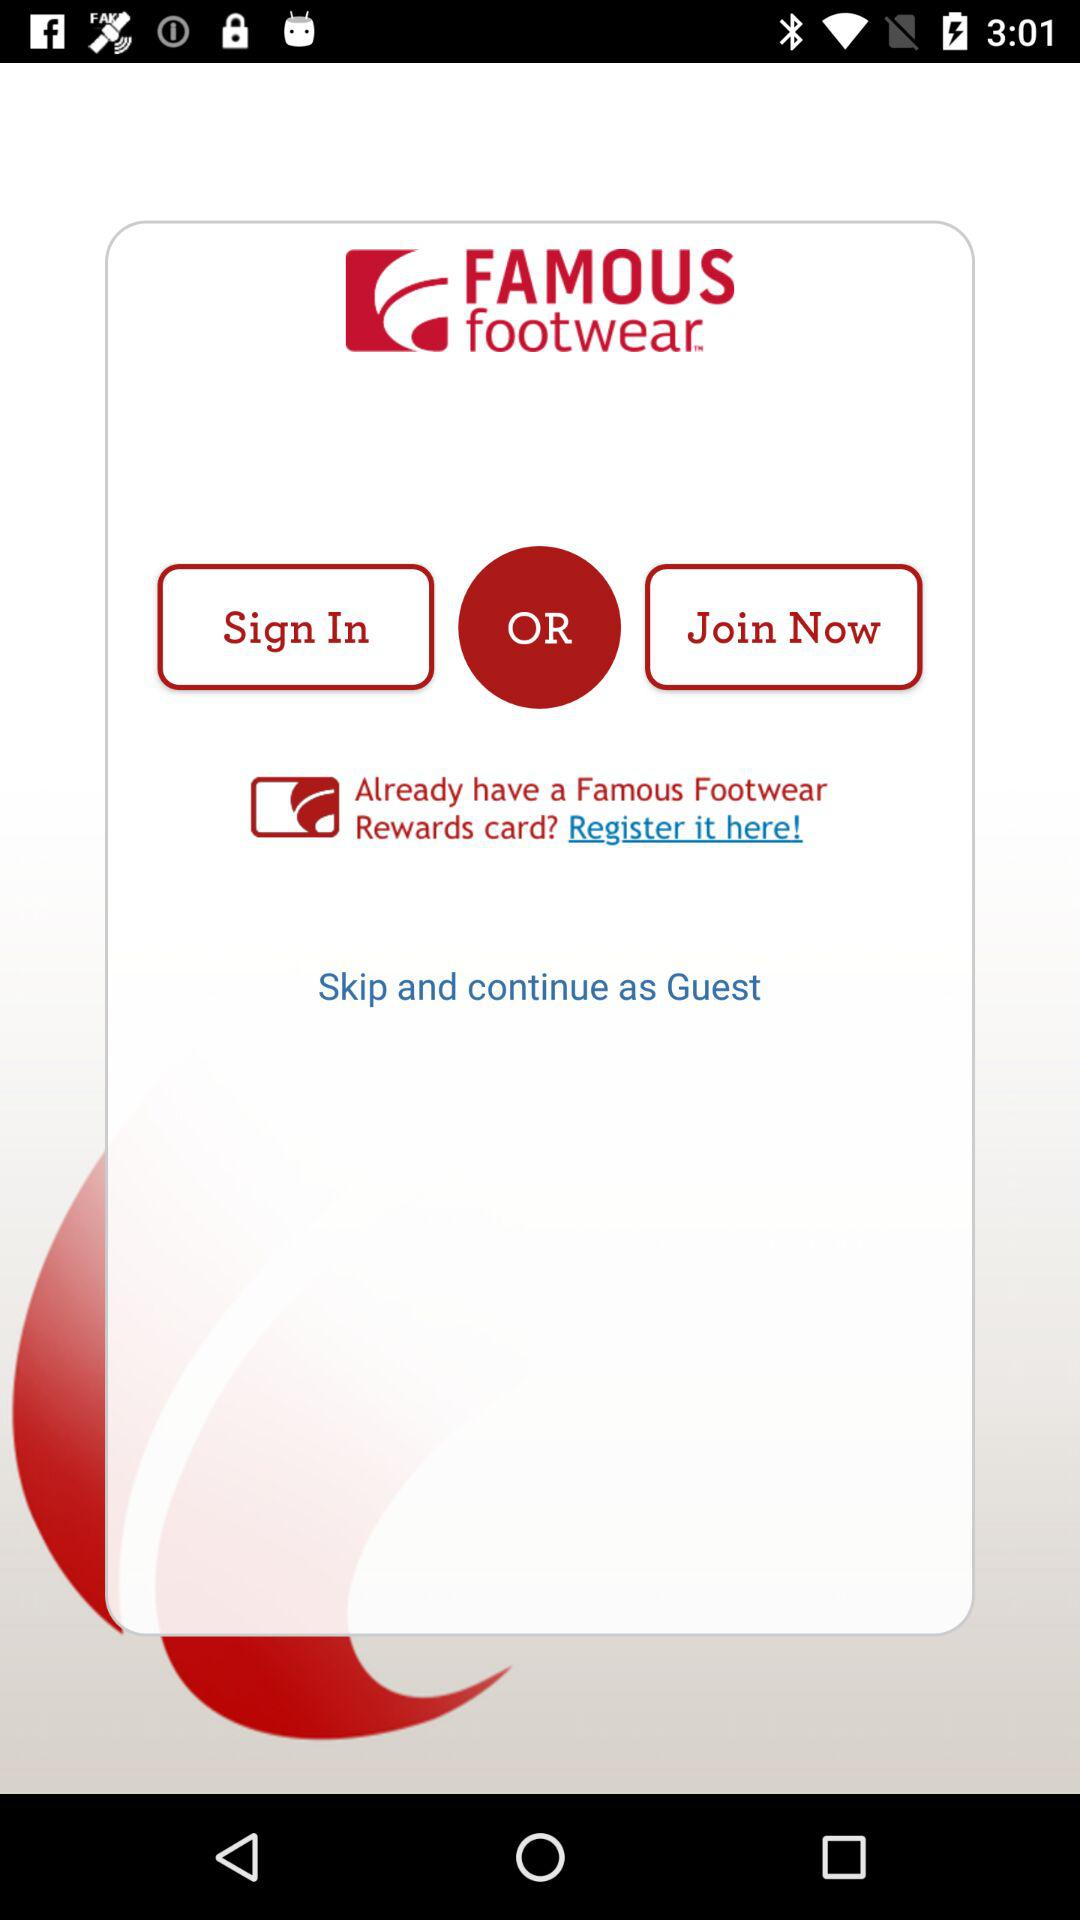How do you join?
When the provided information is insufficient, respond with <no answer>. <no answer> 